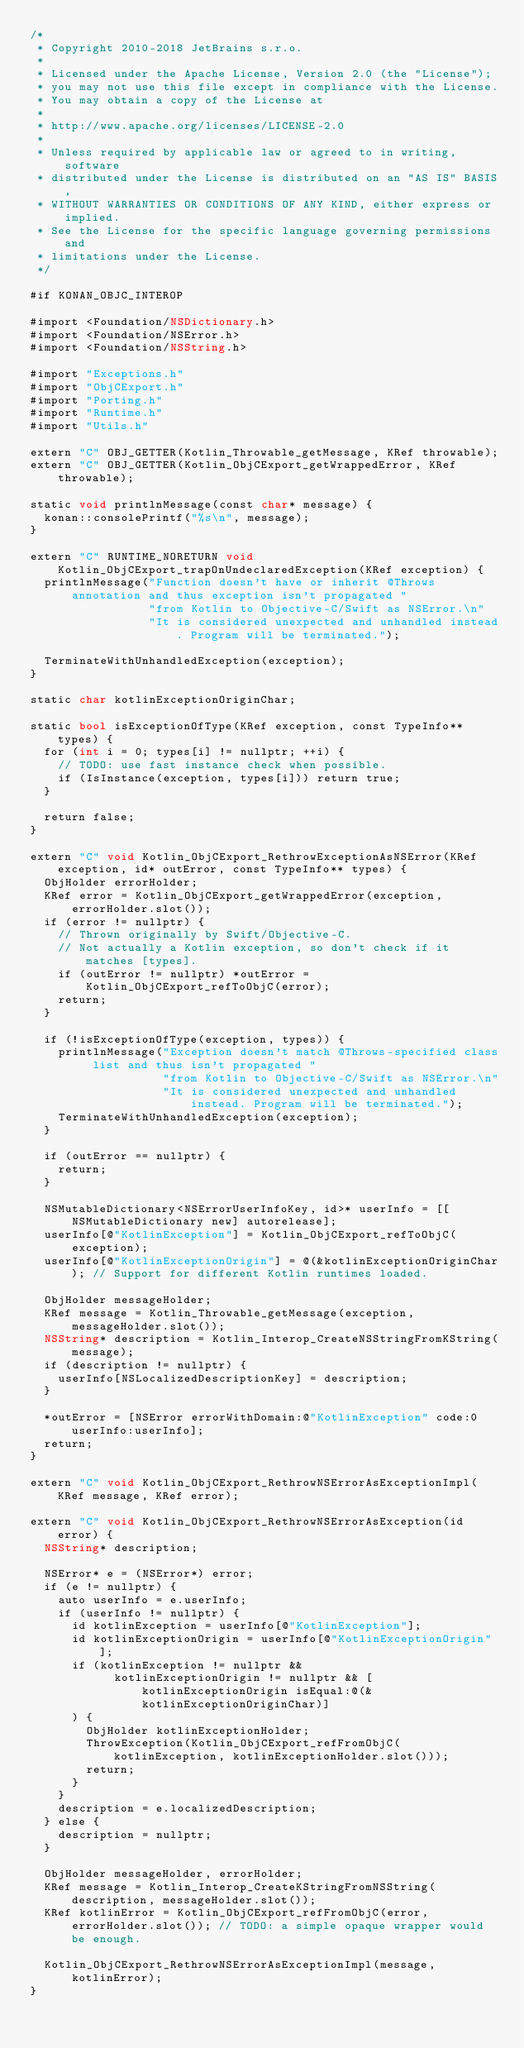Convert code to text. <code><loc_0><loc_0><loc_500><loc_500><_ObjectiveC_>/*
 * Copyright 2010-2018 JetBrains s.r.o.
 *
 * Licensed under the Apache License, Version 2.0 (the "License");
 * you may not use this file except in compliance with the License.
 * You may obtain a copy of the License at
 *
 * http://www.apache.org/licenses/LICENSE-2.0
 *
 * Unless required by applicable law or agreed to in writing, software
 * distributed under the License is distributed on an "AS IS" BASIS,
 * WITHOUT WARRANTIES OR CONDITIONS OF ANY KIND, either express or implied.
 * See the License for the specific language governing permissions and
 * limitations under the License.
 */

#if KONAN_OBJC_INTEROP

#import <Foundation/NSDictionary.h>
#import <Foundation/NSError.h>
#import <Foundation/NSString.h>

#import "Exceptions.h"
#import "ObjCExport.h"
#import "Porting.h"
#import "Runtime.h"
#import "Utils.h"

extern "C" OBJ_GETTER(Kotlin_Throwable_getMessage, KRef throwable);
extern "C" OBJ_GETTER(Kotlin_ObjCExport_getWrappedError, KRef throwable);

static void printlnMessage(const char* message) {
  konan::consolePrintf("%s\n", message);
}

extern "C" RUNTIME_NORETURN void Kotlin_ObjCExport_trapOnUndeclaredException(KRef exception) {
  printlnMessage("Function doesn't have or inherit @Throws annotation and thus exception isn't propagated "
                 "from Kotlin to Objective-C/Swift as NSError.\n"
                 "It is considered unexpected and unhandled instead. Program will be terminated.");

  TerminateWithUnhandledException(exception);
}

static char kotlinExceptionOriginChar;

static bool isExceptionOfType(KRef exception, const TypeInfo** types) {
  for (int i = 0; types[i] != nullptr; ++i) {
    // TODO: use fast instance check when possible.
    if (IsInstance(exception, types[i])) return true;
  }

  return false;
}

extern "C" void Kotlin_ObjCExport_RethrowExceptionAsNSError(KRef exception, id* outError, const TypeInfo** types) {
  ObjHolder errorHolder;
  KRef error = Kotlin_ObjCExport_getWrappedError(exception, errorHolder.slot());
  if (error != nullptr) {
    // Thrown originally by Swift/Objective-C.
    // Not actually a Kotlin exception, so don't check if it matches [types].
    if (outError != nullptr) *outError = Kotlin_ObjCExport_refToObjC(error);
    return;
  }

  if (!isExceptionOfType(exception, types)) {
    printlnMessage("Exception doesn't match @Throws-specified class list and thus isn't propagated "
                   "from Kotlin to Objective-C/Swift as NSError.\n"
                   "It is considered unexpected and unhandled instead. Program will be terminated.");
    TerminateWithUnhandledException(exception);
  }

  if (outError == nullptr) {
    return;
  }

  NSMutableDictionary<NSErrorUserInfoKey, id>* userInfo = [[NSMutableDictionary new] autorelease];
  userInfo[@"KotlinException"] = Kotlin_ObjCExport_refToObjC(exception);
  userInfo[@"KotlinExceptionOrigin"] = @(&kotlinExceptionOriginChar); // Support for different Kotlin runtimes loaded.

  ObjHolder messageHolder;
  KRef message = Kotlin_Throwable_getMessage(exception, messageHolder.slot());
  NSString* description = Kotlin_Interop_CreateNSStringFromKString(message);
  if (description != nullptr) {
    userInfo[NSLocalizedDescriptionKey] = description;
  }

  *outError = [NSError errorWithDomain:@"KotlinException" code:0 userInfo:userInfo];
  return;
}

extern "C" void Kotlin_ObjCExport_RethrowNSErrorAsExceptionImpl(KRef message, KRef error);

extern "C" void Kotlin_ObjCExport_RethrowNSErrorAsException(id error) {
  NSString* description;

  NSError* e = (NSError*) error;
  if (e != nullptr) {
    auto userInfo = e.userInfo;
    if (userInfo != nullptr) {
      id kotlinException = userInfo[@"KotlinException"];
      id kotlinExceptionOrigin = userInfo[@"KotlinExceptionOrigin"];
      if (kotlinException != nullptr &&
            kotlinExceptionOrigin != nullptr && [kotlinExceptionOrigin isEqual:@(&kotlinExceptionOriginChar)]
      ) {
        ObjHolder kotlinExceptionHolder;
        ThrowException(Kotlin_ObjCExport_refFromObjC(kotlinException, kotlinExceptionHolder.slot()));
        return;
      }
    }
    description = e.localizedDescription;
  } else {
    description = nullptr;
  }

  ObjHolder messageHolder, errorHolder;
  KRef message = Kotlin_Interop_CreateKStringFromNSString(description, messageHolder.slot());
  KRef kotlinError = Kotlin_ObjCExport_refFromObjC(error, errorHolder.slot()); // TODO: a simple opaque wrapper would be enough.

  Kotlin_ObjCExport_RethrowNSErrorAsExceptionImpl(message, kotlinError);
}
</code> 